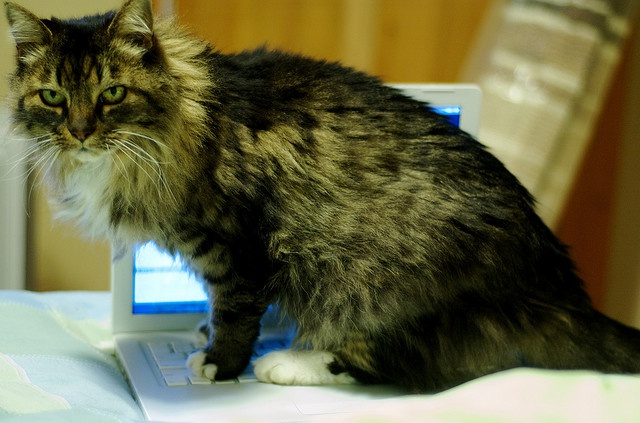Describe the objects in this image and their specific colors. I can see cat in olive, black, and darkgray tones, laptop in olive, white, darkgray, gray, and lightgray tones, and bed in olive, lightblue, darkgray, and gray tones in this image. 